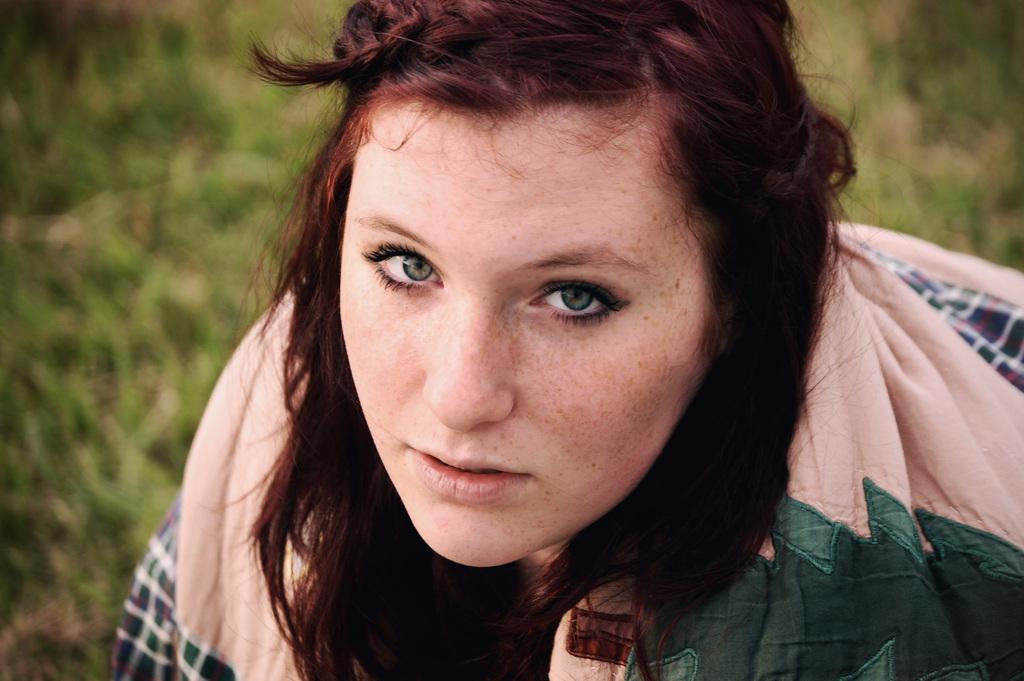Please provide a concise description of this image. As we can see in the image there is a woman and there is grass. 